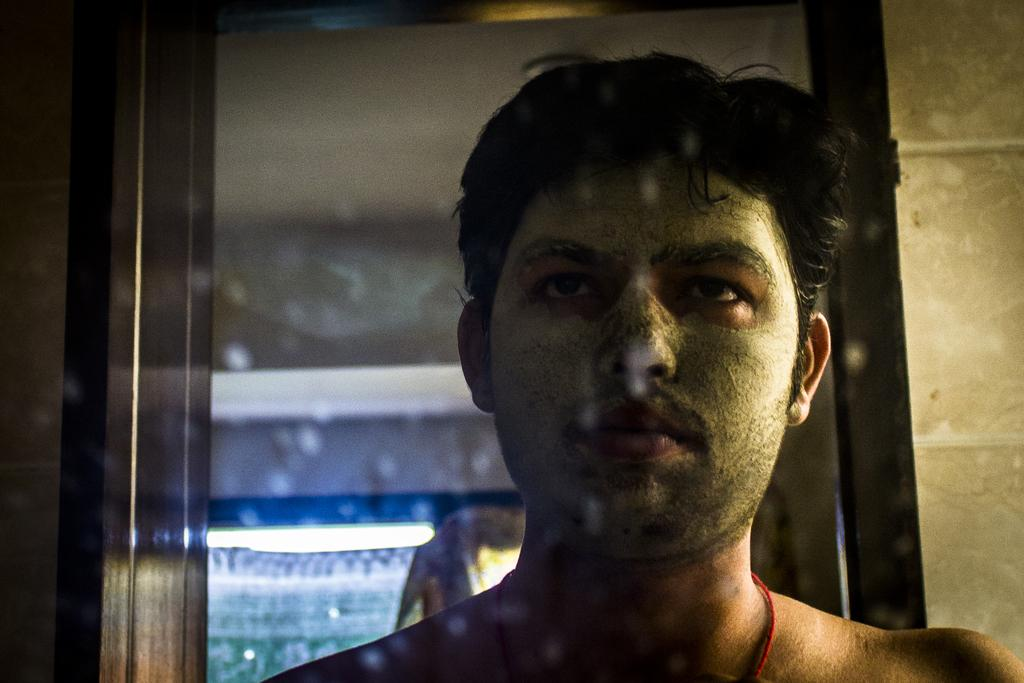What object is present in the image that can show reflections? There is a mirror in the image. Can you describe what is being reflected in the mirror? The mirror has the reflection of a person. What type of lighting is present in the image? There is a light attached to the roof in the image. What type of straw is being used by the person in the image? There is no straw present in the image; it only features a mirror with a person's reflection and a light attached to the roof. 